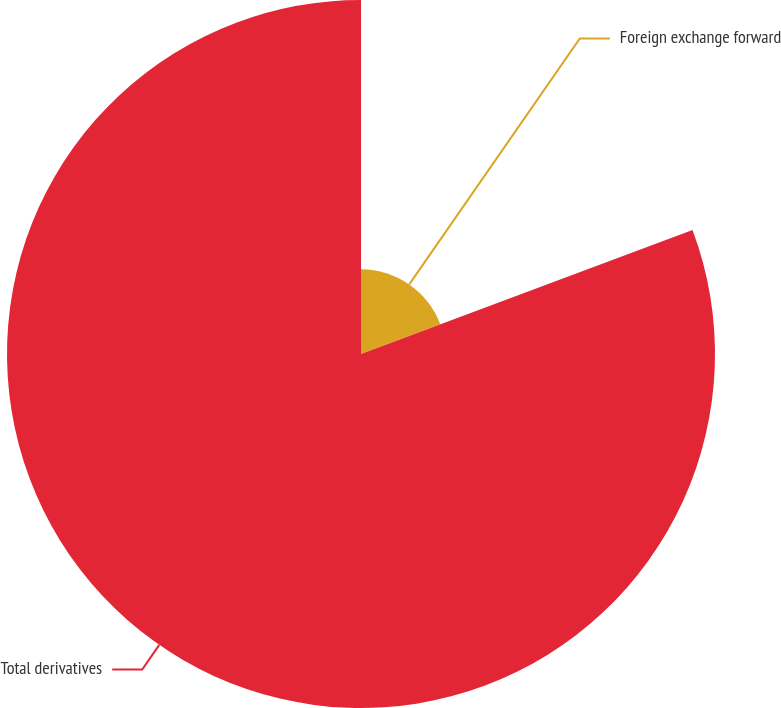<chart> <loc_0><loc_0><loc_500><loc_500><pie_chart><fcel>Foreign exchange forward<fcel>Total derivatives<nl><fcel>19.3%<fcel>80.7%<nl></chart> 